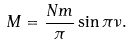<formula> <loc_0><loc_0><loc_500><loc_500>M = \frac { N m } { \pi } \sin \pi \nu .</formula> 